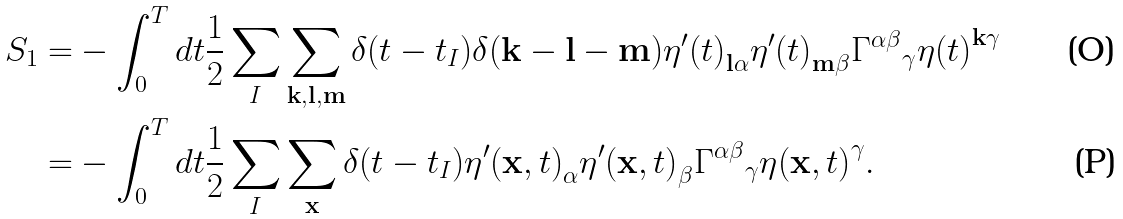Convert formula to latex. <formula><loc_0><loc_0><loc_500><loc_500>S _ { 1 } = & - \int _ { 0 } ^ { T } d t \frac { 1 } { 2 } \sum _ { I } \sum _ { { \mathbf k } , { \mathbf l } , { \mathbf m } } \delta ( t - t _ { I } ) \delta ( { \mathbf k } - { \mathbf l } - { \mathbf m } ) { \eta ^ { \prime } ( t ) } _ { { \mathbf l } \alpha } { \eta ^ { \prime } ( t ) } _ { { \mathbf m } \beta } { \Gamma ^ { \alpha \beta } } _ { \gamma } { \eta ( t ) } ^ { { \mathbf k } \gamma } \\ = & - \int _ { 0 } ^ { T } d t \frac { 1 } { 2 } \sum _ { I } \sum _ { \mathbf x } \delta ( t - t _ { I } ) { \eta ^ { \prime } ( { \mathbf x } , t ) } _ { \alpha } { \eta ^ { \prime } ( { \mathbf x } , t ) } _ { \beta } { \Gamma ^ { \alpha \beta } } _ { \gamma } { \eta ( { \mathbf x } , t ) } ^ { \gamma } .</formula> 